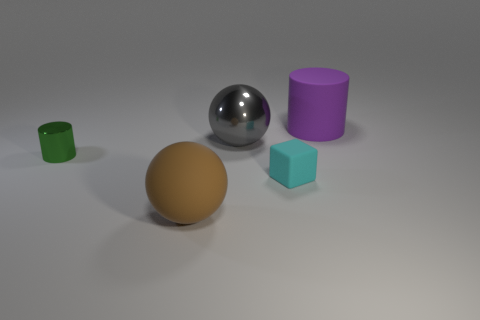There is a big thing in front of the cyan rubber object; is it the same shape as the big gray thing?
Offer a terse response. Yes. Is there any other thing that has the same material as the brown object?
Offer a very short reply. Yes. There is a thing that is on the left side of the small cyan cube and on the right side of the brown matte ball; what is its size?
Keep it short and to the point. Large. Is the number of cyan rubber things in front of the small metal cylinder greater than the number of big shiny objects in front of the big brown rubber object?
Offer a terse response. Yes. Does the big purple object have the same shape as the metallic thing that is on the left side of the gray metal sphere?
Offer a terse response. Yes. There is a large thing that is both behind the tiny block and in front of the large purple matte object; what color is it?
Your response must be concise. Gray. Is the gray thing made of the same material as the cylinder to the left of the cyan matte object?
Provide a short and direct response. Yes. What shape is the small cyan object that is made of the same material as the brown sphere?
Your answer should be compact. Cube. There is a thing that is the same size as the cyan rubber block; what is its color?
Offer a very short reply. Green. There is a ball that is behind the cyan matte cube; is it the same size as the cyan block?
Provide a short and direct response. No. 